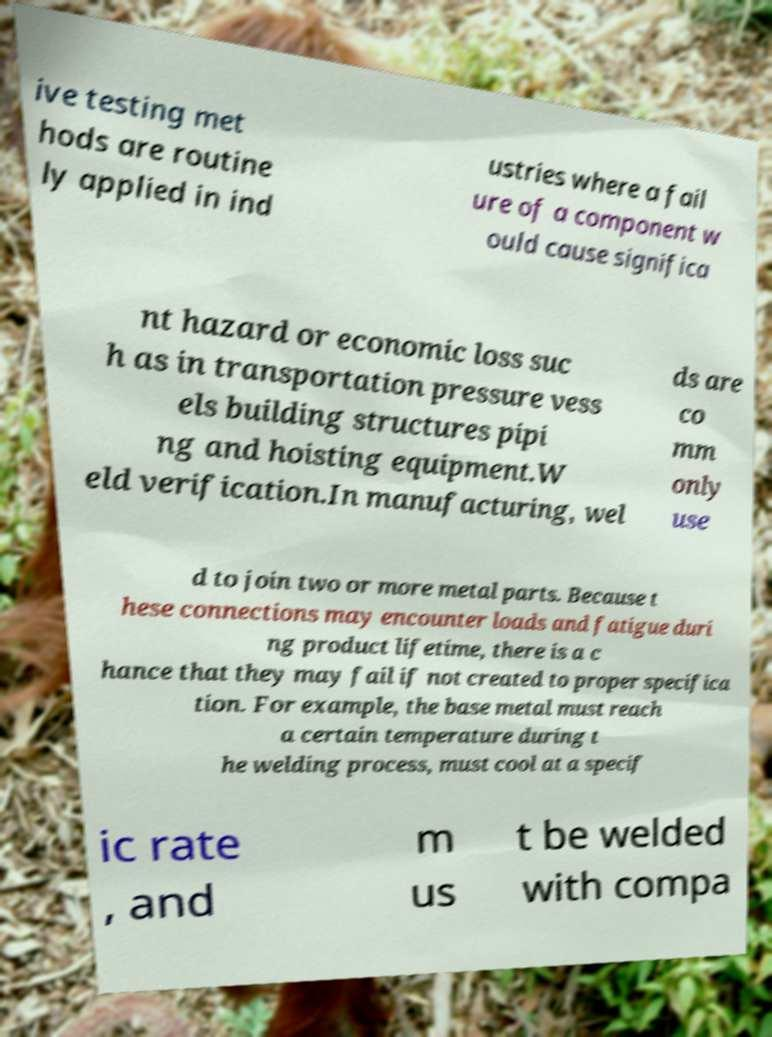Please identify and transcribe the text found in this image. ive testing met hods are routine ly applied in ind ustries where a fail ure of a component w ould cause significa nt hazard or economic loss suc h as in transportation pressure vess els building structures pipi ng and hoisting equipment.W eld verification.In manufacturing, wel ds are co mm only use d to join two or more metal parts. Because t hese connections may encounter loads and fatigue duri ng product lifetime, there is a c hance that they may fail if not created to proper specifica tion. For example, the base metal must reach a certain temperature during t he welding process, must cool at a specif ic rate , and m us t be welded with compa 